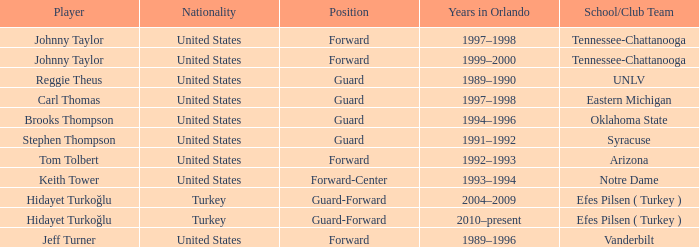What is the Position of the player from Vanderbilt? Forward. 